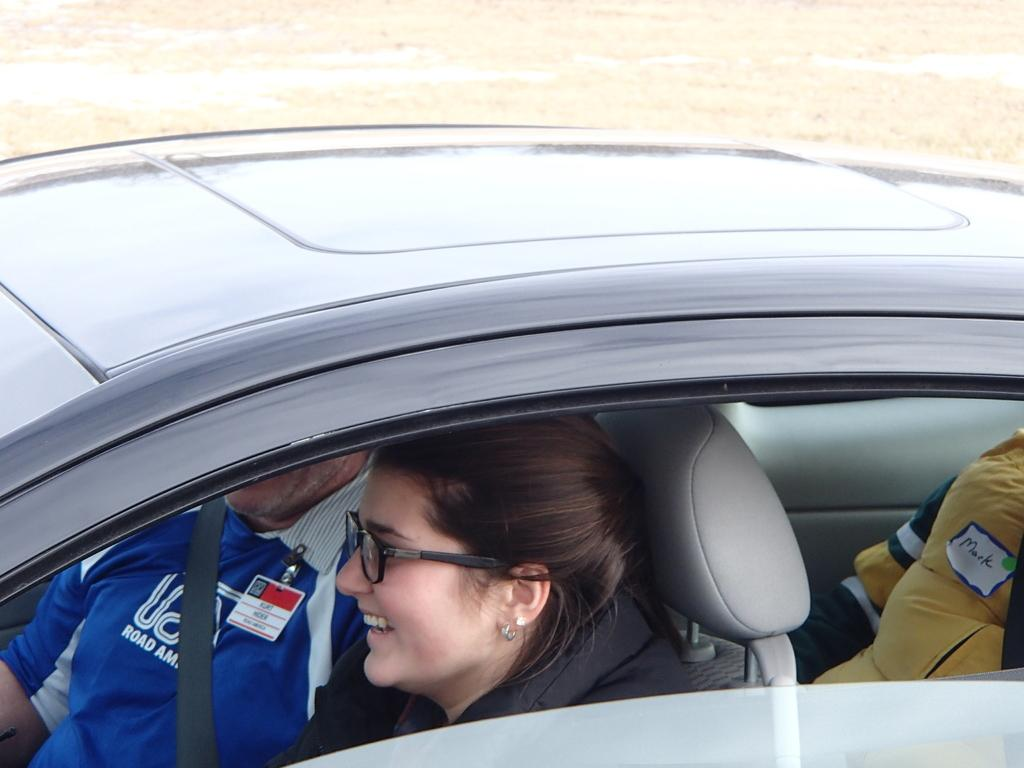What are the people in the image doing? The people are sitting inside a car in the image. What can be seen in the background of the image? There is grass and water visible in the background of the image. What type of apparatus is being used to measure the temperature of the water in the image? There is no apparatus present in the image for measuring the temperature of the water. 